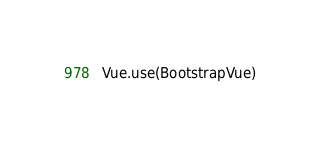Convert code to text. <code><loc_0><loc_0><loc_500><loc_500><_JavaScript_>
Vue.use(BootstrapVue)
</code> 